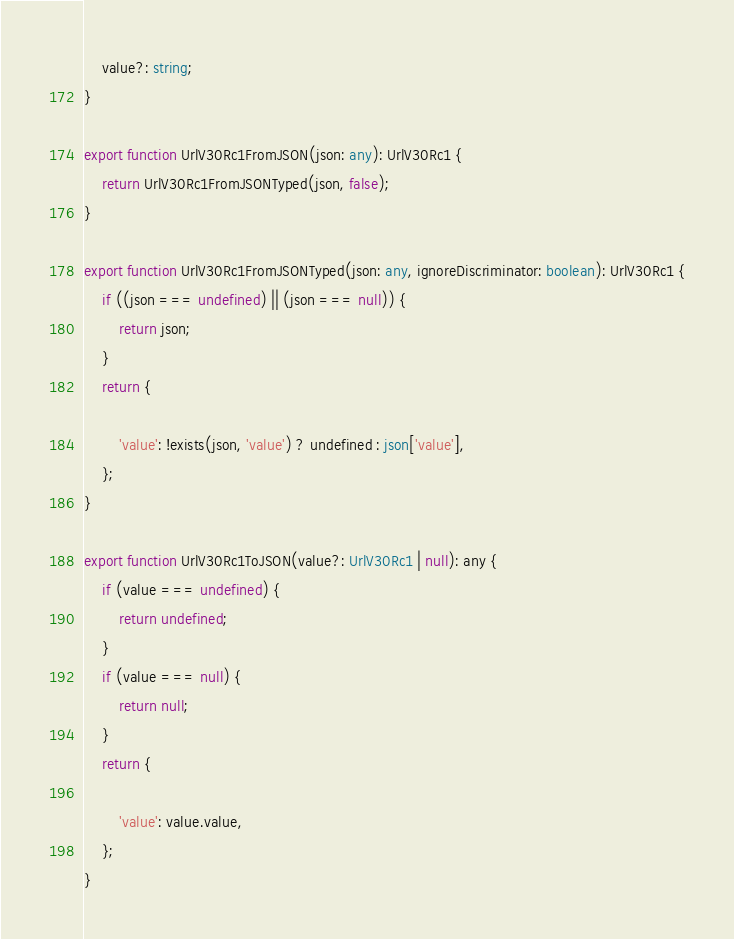Convert code to text. <code><loc_0><loc_0><loc_500><loc_500><_TypeScript_>    value?: string;
}

export function UrlV30Rc1FromJSON(json: any): UrlV30Rc1 {
    return UrlV30Rc1FromJSONTyped(json, false);
}

export function UrlV30Rc1FromJSONTyped(json: any, ignoreDiscriminator: boolean): UrlV30Rc1 {
    if ((json === undefined) || (json === null)) {
        return json;
    }
    return {
        
        'value': !exists(json, 'value') ? undefined : json['value'],
    };
}

export function UrlV30Rc1ToJSON(value?: UrlV30Rc1 | null): any {
    if (value === undefined) {
        return undefined;
    }
    if (value === null) {
        return null;
    }
    return {
        
        'value': value.value,
    };
}


</code> 